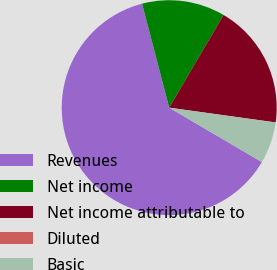Convert chart. <chart><loc_0><loc_0><loc_500><loc_500><pie_chart><fcel>Revenues<fcel>Net income<fcel>Net income attributable to<fcel>Diluted<fcel>Basic<nl><fcel>62.49%<fcel>12.5%<fcel>18.75%<fcel>0.01%<fcel>6.25%<nl></chart> 